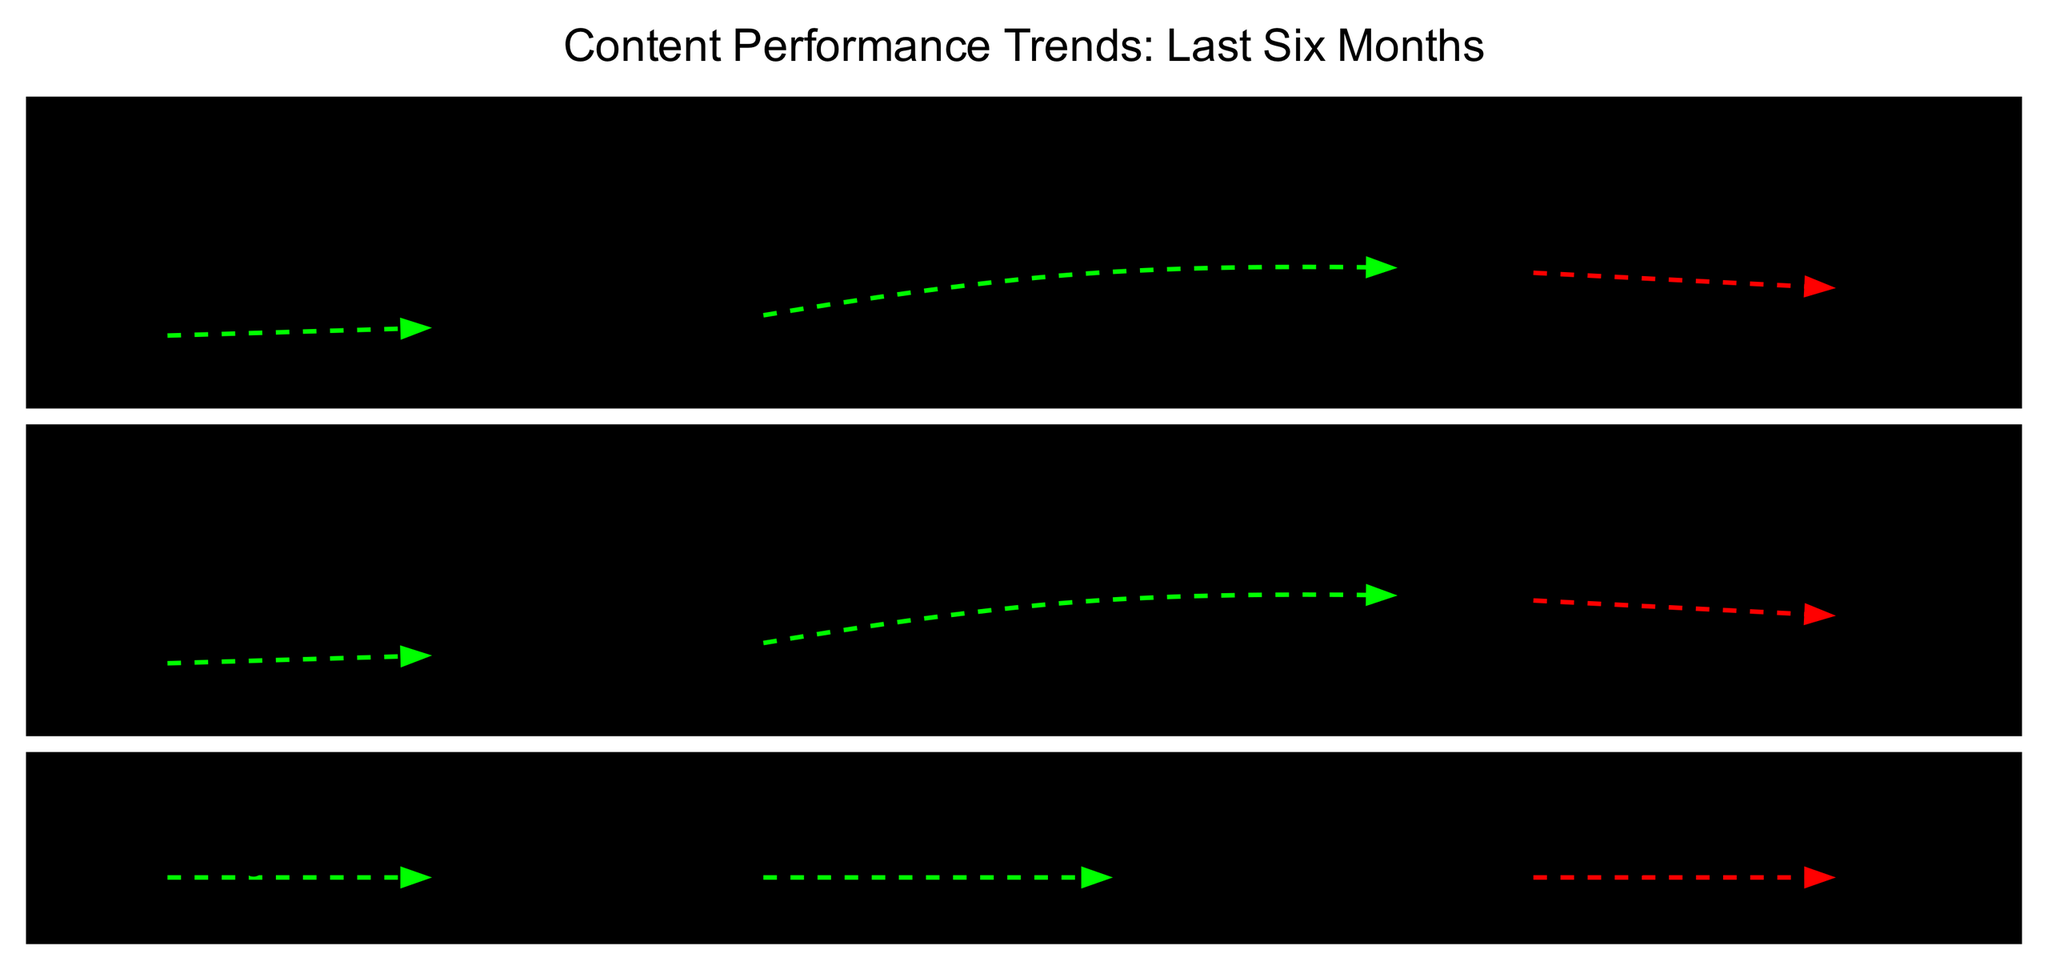What was the engagement rate for photos in October? The diagram indicates the performance record for photos, where October is associated with an engagement rate of 30%.
Answer: 30% What trend is observed for videos from August to October? Analyzing the trend line in the diagram, it shows significant growth from August to October for videos.
Answer: Significant Growth What was the completion rate for stories in November? Looking at the stories' performance in November, the completion rate is noted as 78%.
Answer: 78% How many types of content are represented in the diagram? The diagram includes three content types: Photos, Videos, and Stories.
Answer: Three What trend was observed for photos between August and September? By checking the trend line specifically for photos, there is a significant growth recorded between August and September.
Answer: Significant Growth What was the views metric for videos in July? Referring to the performance details for videos, the views metric for July was 3500.
Answer: 3500 What is the overall trend for stories from June to November? Observing the trends for stories in the timeline, there was mild growth, followed by significant growth, and then a moderate decline from June to November.
Answer: Mild Growth, Significant Growth, Moderate Decline What was the lowest engagement rate for photos over the six months? Among the engagement rates listed for each month, the lowest value for photos is 18%, which occurred in August.
Answer: 18% What connection can be seen between the October and November performance for videos? The diagram indicates that there is a slight decline in video views from October (5200) to November (4800).
Answer: Slight Decline 